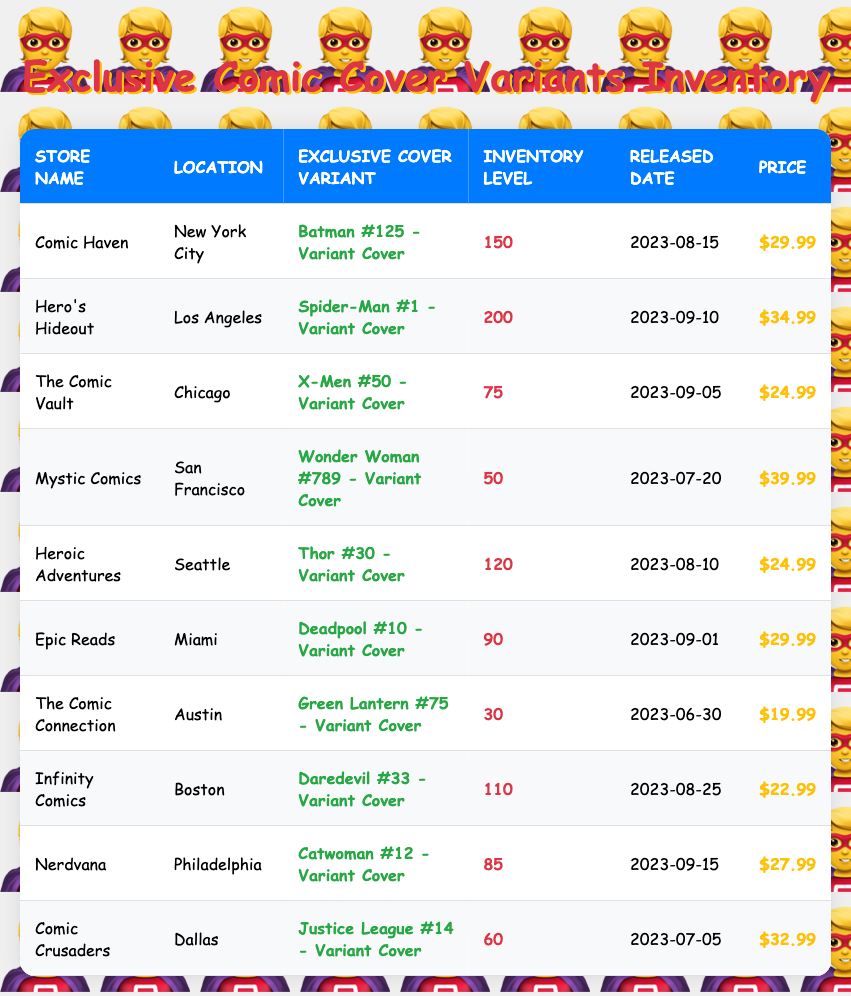What is the store with the highest inventory level? The store with the highest inventory level can be found by looking for the maximum value in the "Inventory Level" column. By scanning the table, "Hero's Hideout" has an inventory of 200, which is the highest.
Answer: Hero's Hideout How many exclusive cover variants are listed in the table? To find the number of exclusive cover variants, count the number of rows in the table. There are 10 rows, each corresponding to a unique exclusive cover variant.
Answer: 10 Which exclusive cover variant has the highest price? The exclusive cover variant with the highest price can be determined by reviewing the "Price" column. "Wonder Woman #789 - Variant Cover" has a price of $39.99, which is the highest.
Answer: Wonder Woman #789 - Variant Cover What is the average inventory level across all stores? To calculate the average, first, sum all inventory levels: (150 + 200 + 75 + 50 + 120 + 90 + 30 + 110 + 85 + 60) = 1,070. Then, divide by the number of stores (10): 1,070 / 10 = 107.
Answer: 107 Is there any store with an inventory level below 50? Scan the "Inventory Level" column for values below 50. "Mystic Comics" has an inventory level of 50, and "The Comic Connection" has 30, which is below 50.
Answer: Yes How many exclusive cover variants were released after August 1, 2023? Identify the release dates in the table after August 1, 2023. The variants released after that date are: "Batman #125 - Variant Cover," "Spider-Man #1 - Variant Cover," "X-Men #50 - Variant Cover," "Thor #30 - Variant Cover," "Deadpool #10 - Variant Cover," "Daredevil #33 - Variant Cover," and "Catwoman #12 - Variant Cover." Counting these gives us a total of 7.
Answer: 7 What is the total inventory level for all stores that are located in the East? Identify stores located in Eastern cities (e.g., New York City, Philadelphia, Boston) and sum their inventory levels: Comic Haven (150) + Nerdvana (85) + Infinity Comics (110) = 345.
Answer: 345 Which store's exclusive cover variant was released the earliest? Check the "Released Date" column for the earliest date. "The Comic Connection" has the earliest release date of 2023-06-30.
Answer: The Comic Connection Is "Epic Reads" located in a state that has a comic book store with a higher inventory level? Compare "Epic Reads" in Miami (inventory 90) with other store inventories. "Hero's Hideout" has 200, which is higher.
Answer: Yes What is the difference in inventory levels between the store with the highest and the store with the lowest inventory? The highest inventory is 200 (Hero's Hideout) and the lowest is 30 (The Comic Connection). The difference is 200 - 30 = 170.
Answer: 170 